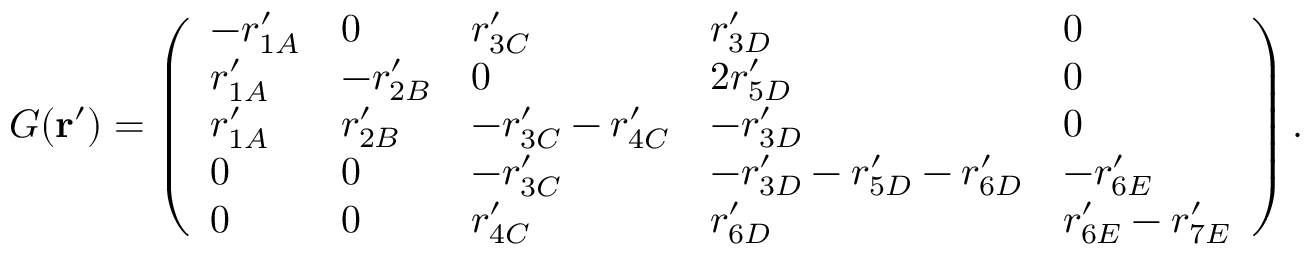<formula> <loc_0><loc_0><loc_500><loc_500>G ( r ^ { \prime } ) = \left ( \begin{array} { l l l l l } { - r _ { 1 A } ^ { \prime } } & { 0 } & { r _ { 3 C } ^ { \prime } } & { r _ { 3 D } ^ { \prime } } & { 0 } \\ { r _ { 1 A } ^ { \prime } } & { - r _ { 2 B } ^ { \prime } } & { 0 } & { 2 r _ { 5 D } ^ { \prime } } & { 0 } \\ { r _ { 1 A } ^ { \prime } } & { r _ { 2 B } ^ { \prime } } & { - r _ { 3 C } ^ { \prime } - r _ { 4 C } ^ { \prime } } & { - r _ { 3 D } ^ { \prime } } & { 0 } \\ { 0 } & { 0 } & { - r _ { 3 C } ^ { \prime } } & { - r _ { 3 D } ^ { \prime } - r _ { 5 D } ^ { \prime } - r _ { 6 D } ^ { \prime } } & { - r _ { 6 E } ^ { \prime } } \\ { 0 } & { 0 } & { r _ { 4 C } ^ { \prime } } & { r _ { 6 D } ^ { \prime } } & { r _ { 6 E } ^ { \prime } - r _ { 7 E } ^ { \prime } } \end{array} \right ) .</formula> 